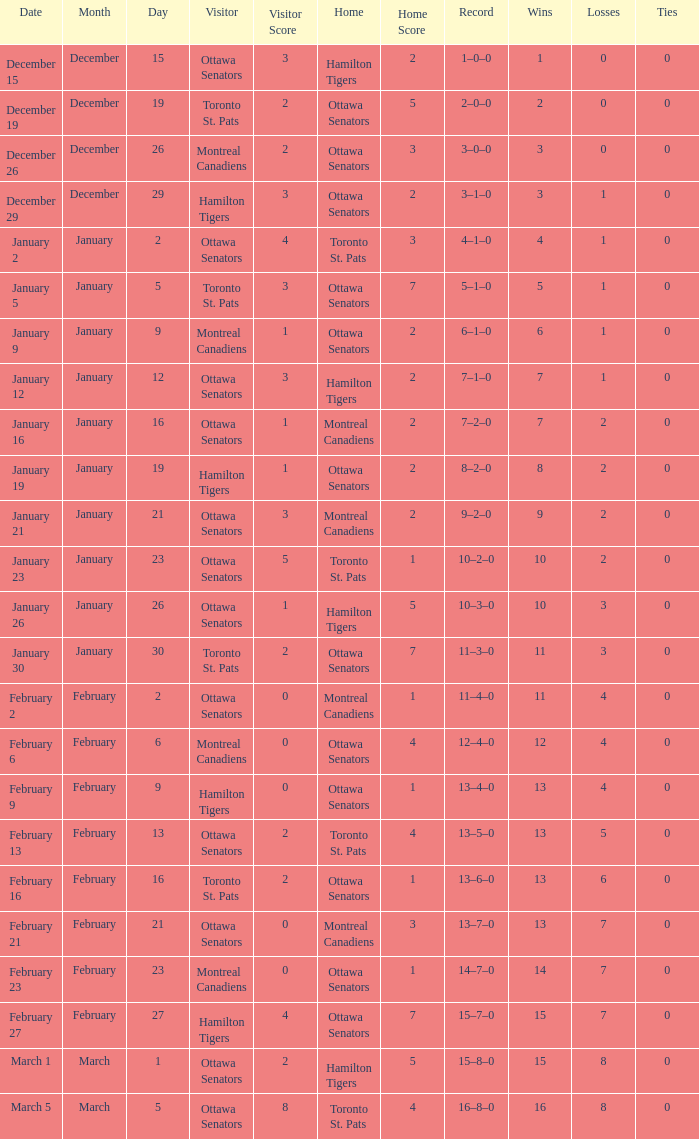What was the score on January 12? 3–2. 